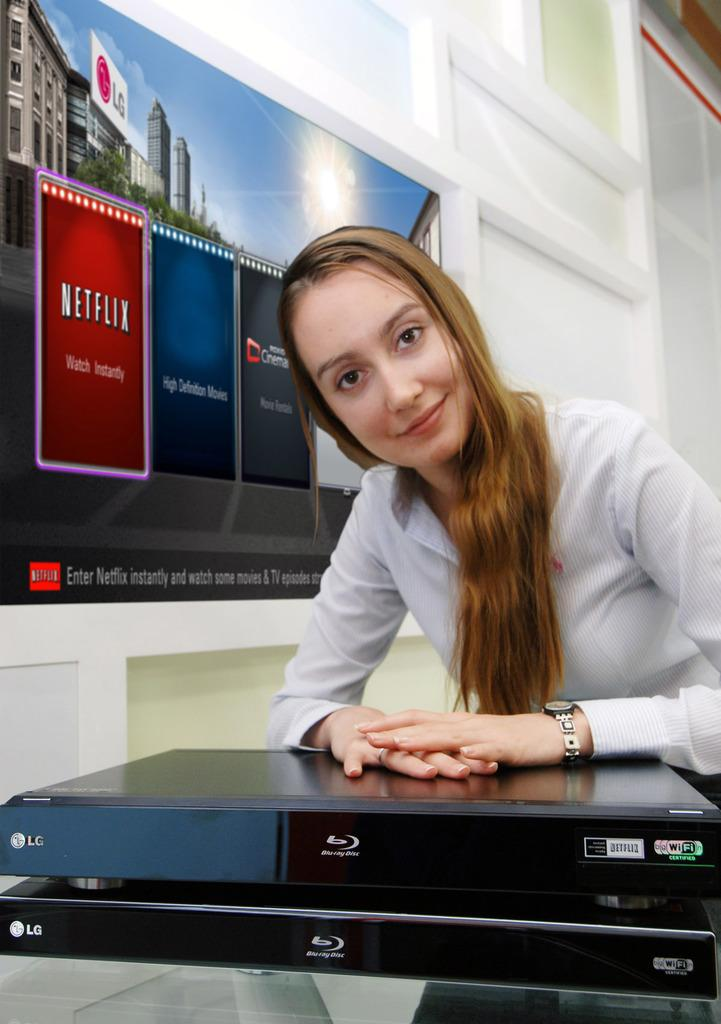<image>
Present a compact description of the photo's key features. A long haired woman sitting in front of an advert for Netflix. 